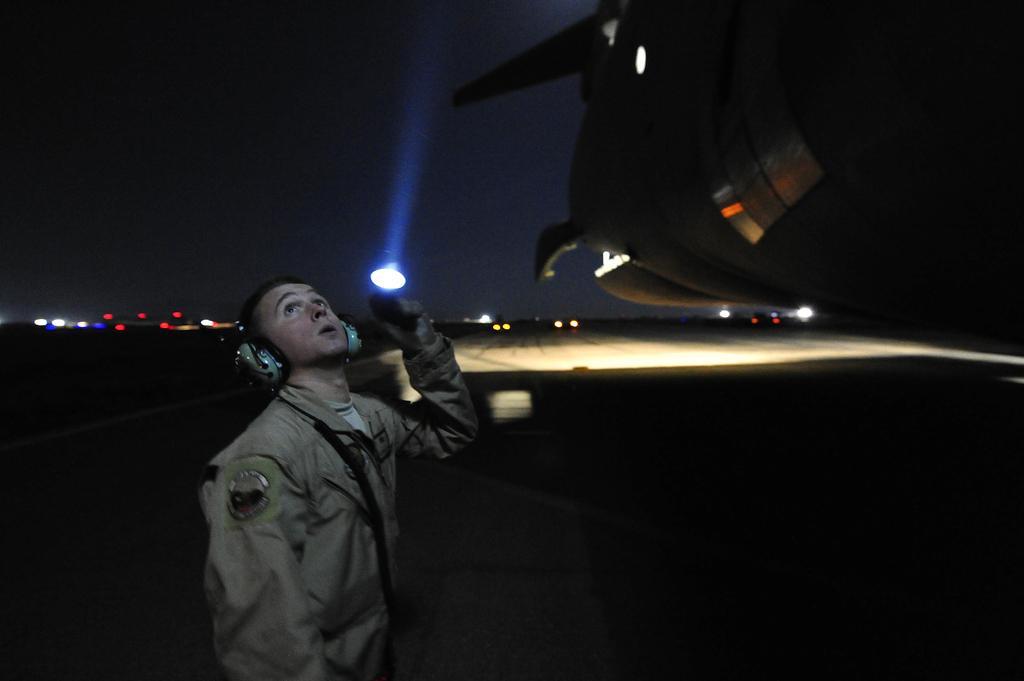In one or two sentences, can you explain what this image depicts? In this picture we can see a man, lights, some objects and in the background we can see the sky. 